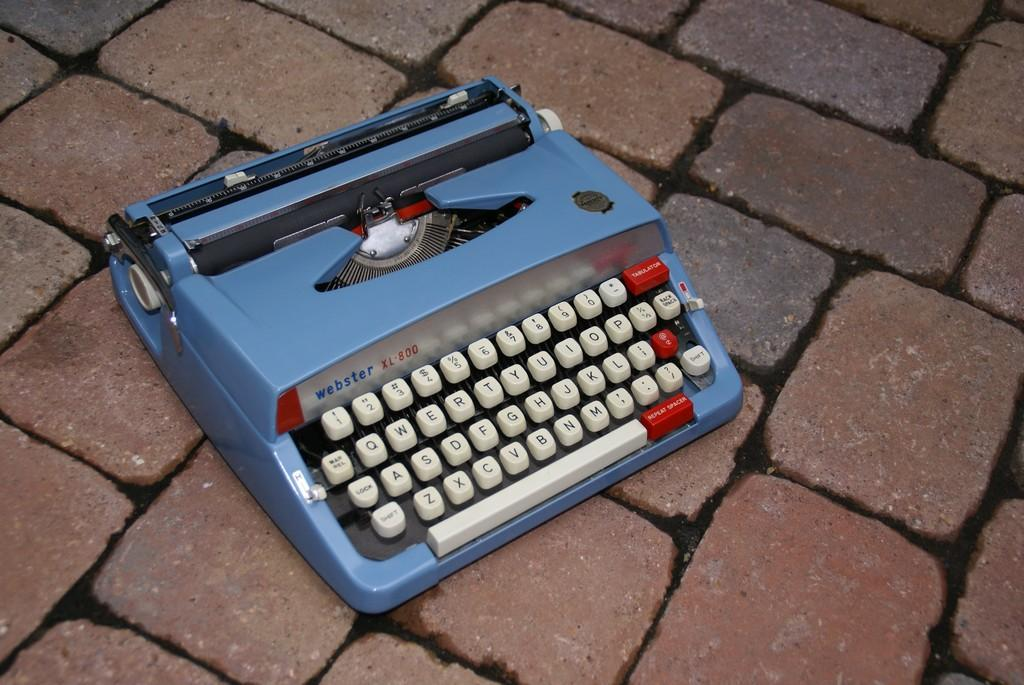<image>
Give a short and clear explanation of the subsequent image. Blue webster xl 800 typewriter on top of some bricks 